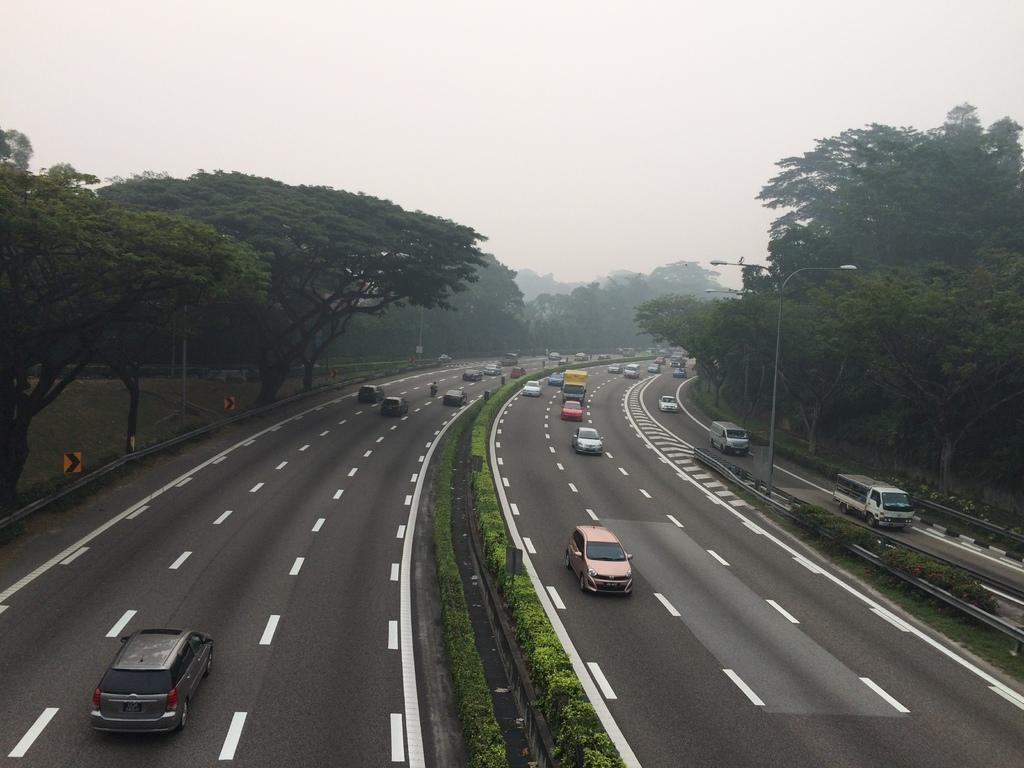What can be seen on the road in the image? There are vehicles on the road in the image. What structures are present alongside the road? There are light poles in the image. What type of vegetation is visible in the image? There are trees with green color in the image. What is the color of the sky in the image? The sky appears to be white in the image. Where is the library located in the image? There is no library present in the image. What type of paste is being used by the tramp in the image? There is no tramp present in the image, so it is not possible to determine what type of paste they might be using. 